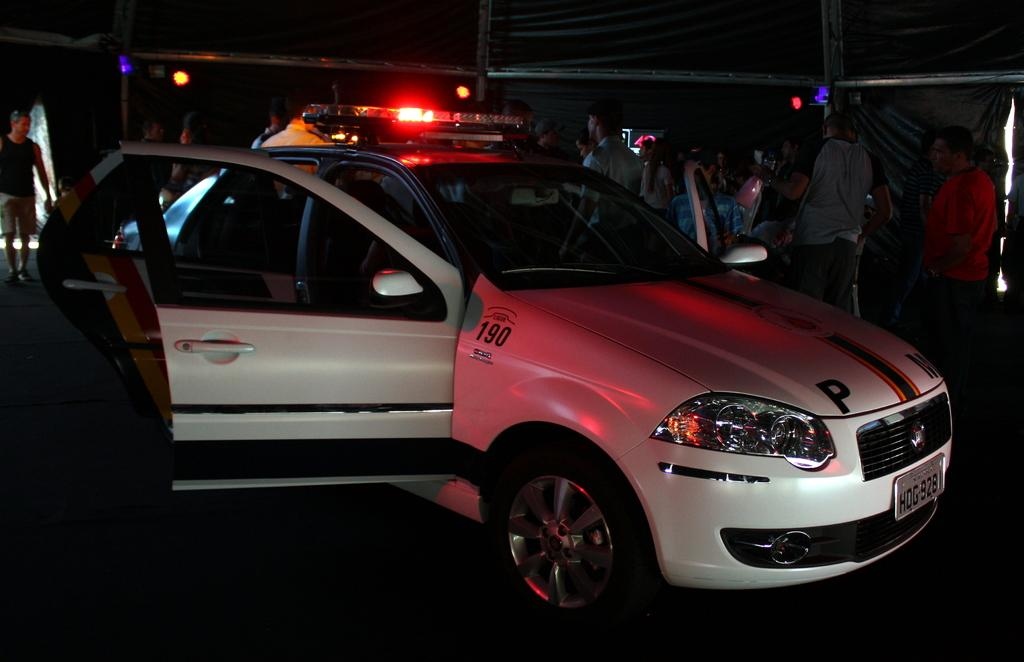What is the main subject of the image? The main subject of the image is a car. What specific features can be seen on the car? The car has lights on it. What else is visible in the background of the image? There is a group of people standing in the background. How would you describe the overall lighting in the image? The background of the image is dark. What color is the car in the image? The car is white in color. How many boys are sitting on the rock in the image? There is no rock or boys present in the image. What type of mailbox is visible near the car in the image? There is no mailbox present in the image. 